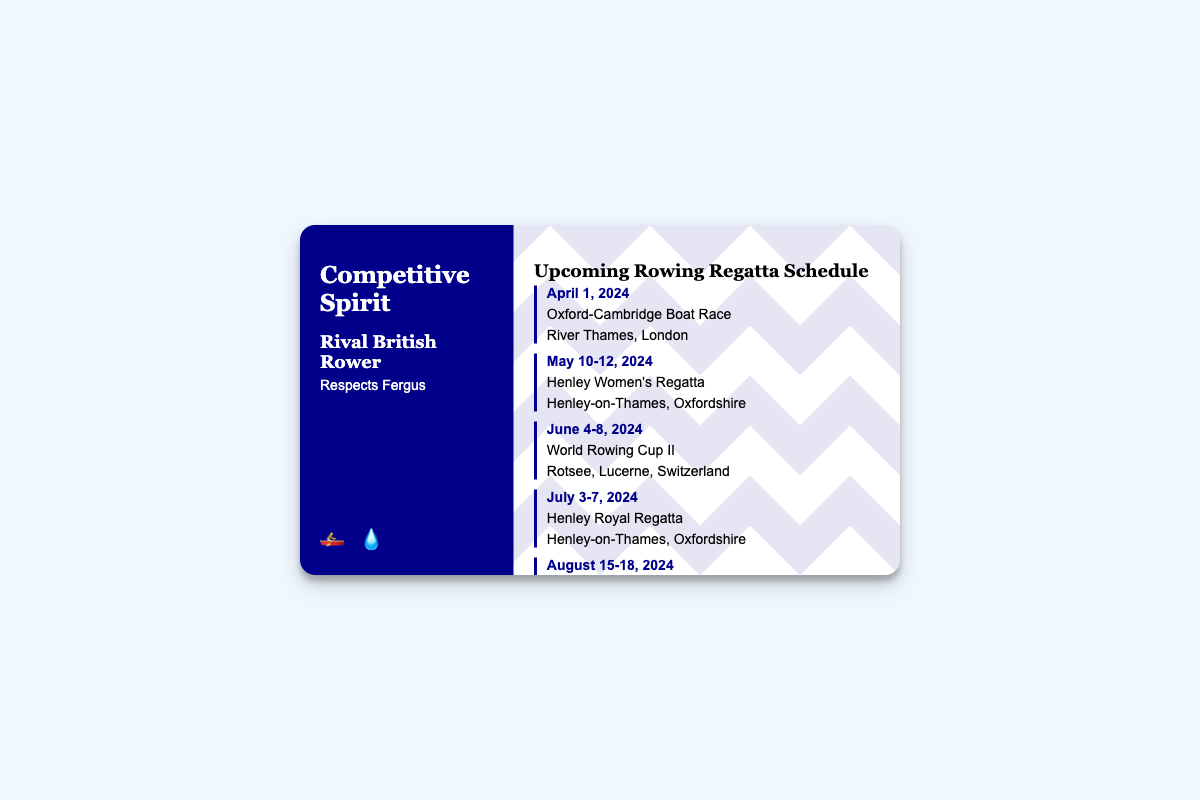What is the date of the Oxford-Cambridge Boat Race? The date mentioned for the Oxford-Cambridge Boat Race in the document is April 1, 2024.
Answer: April 1, 2024 Where is the Henley Women's Regatta held? The location for the Henley Women's Regatta, as stated in the document, is Henley-on-Thames, Oxfordshire.
Answer: Henley-on-Thames, Oxfordshire How many days is the World Rowing Cup II scheduled for? The World Rowing Cup II is scheduled from June 4 to June 8, 2024, which spans 5 days.
Answer: 5 days What type of document is this? This document is a business card specifically designed to showcase a rowing schedule.
Answer: Business card What are the highlighted colors in the design of the card? The primary color highlighted in the design of the card is dark blue, represented as #00008b.
Answer: Dark blue Which event takes place in Munich, Germany? The event scheduled to take place in Munich, Germany, is the European Rowing Championships.
Answer: European Rowing Championships How many regattas are listed in the document? There are six upcoming regattas listed in the document.
Answer: Six What is the venue for the World Rowing Championships? The venue for the World Rowing Championships is specified as Aiguebelette, France.
Answer: Aiguebelette, France When does the Henley Royal Regatta occur? The Henley Royal Regatta is mentioned to occur from July 3 to July 7, 2024.
Answer: July 3-7, 2024 